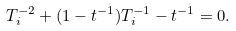Convert formula to latex. <formula><loc_0><loc_0><loc_500><loc_500>T _ { i } ^ { - 2 } + ( 1 - t ^ { - 1 } ) T _ { i } ^ { - 1 } - t ^ { - 1 } = 0 .</formula> 